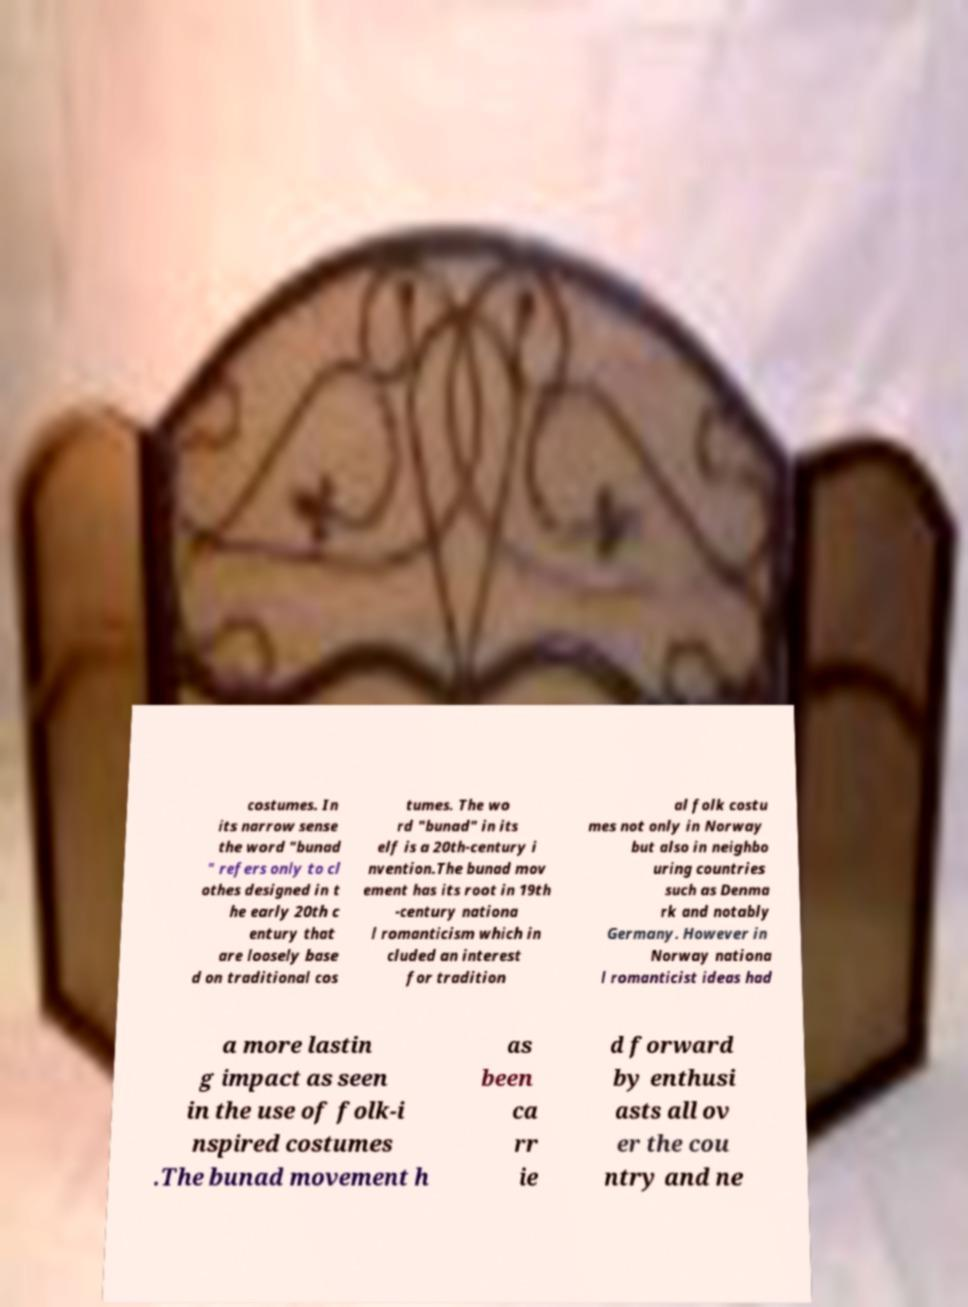Please identify and transcribe the text found in this image. costumes. In its narrow sense the word "bunad " refers only to cl othes designed in t he early 20th c entury that are loosely base d on traditional cos tumes. The wo rd "bunad" in its elf is a 20th-century i nvention.The bunad mov ement has its root in 19th -century nationa l romanticism which in cluded an interest for tradition al folk costu mes not only in Norway but also in neighbo uring countries such as Denma rk and notably Germany. However in Norway nationa l romanticist ideas had a more lastin g impact as seen in the use of folk-i nspired costumes .The bunad movement h as been ca rr ie d forward by enthusi asts all ov er the cou ntry and ne 